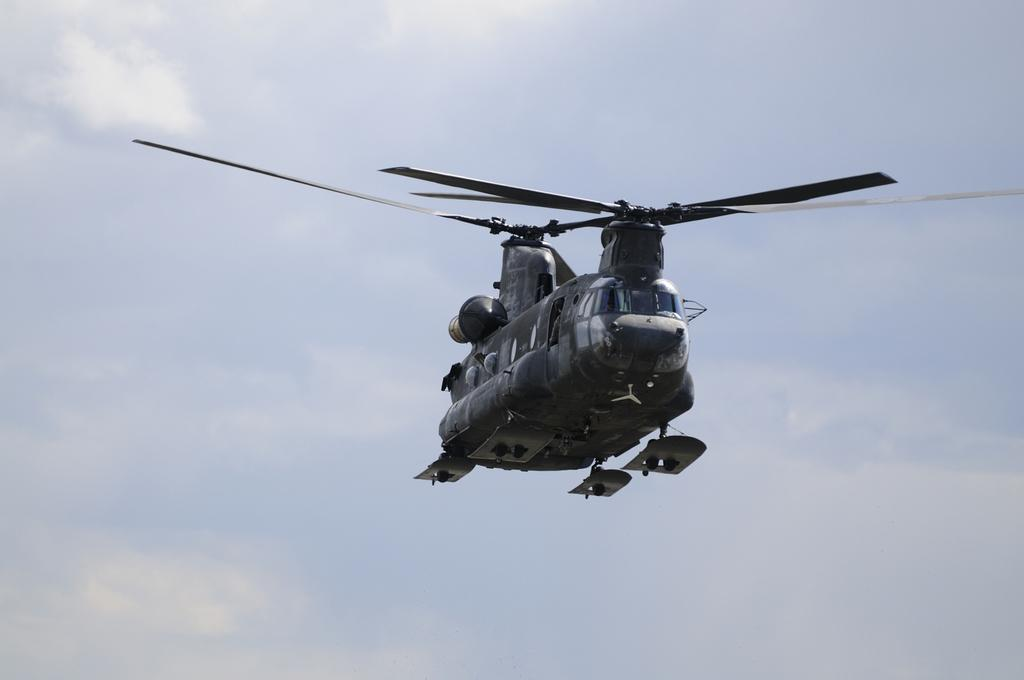What type of aircraft is in the image? There is a military helicopter in the image. What is the helicopter doing in the image? The helicopter is flying in the air. What can be seen in the background of the image? There is a sky visible in the background of the image. What is the condition of the sky in the image? There are clouds in the sky. What type of juice is being served in the helicopter in the image? There is no juice or indication of any food or drink being served in the helicopter in the image. 